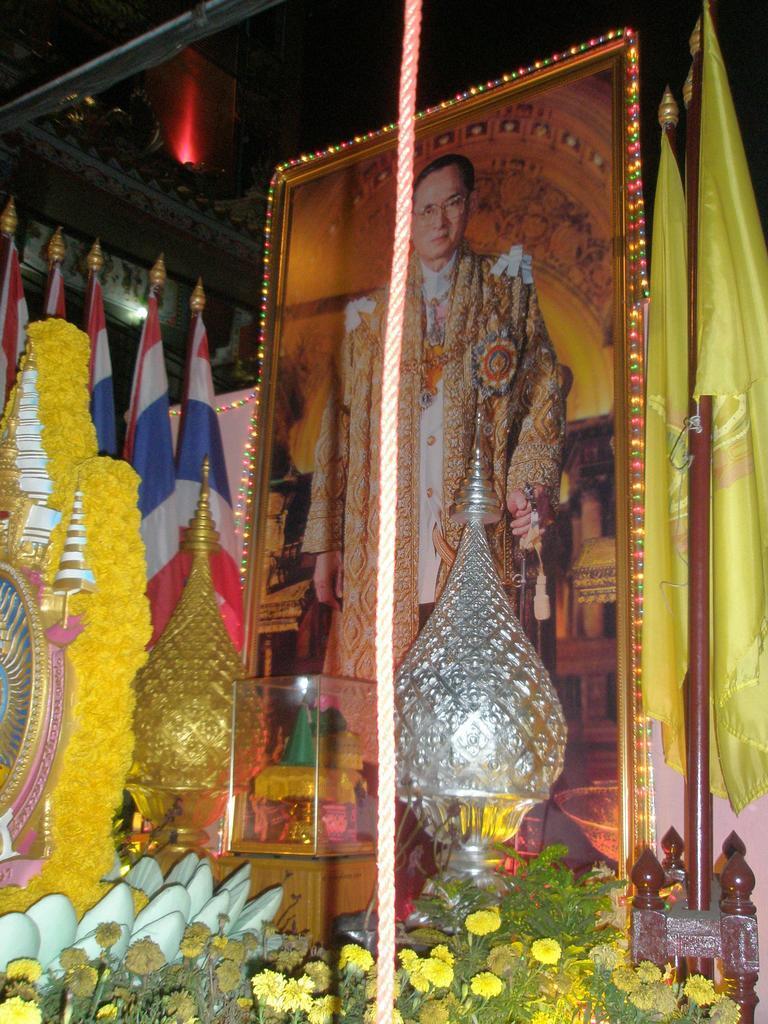Can you describe this image briefly? In this image I can see the frame. In the frame I can see person with the dress. In-front of the person I can see many decorative objects and the flowers. I can see these flowers are in yellow and brown color. To the side of the frame I can see many flags which are colorful. 